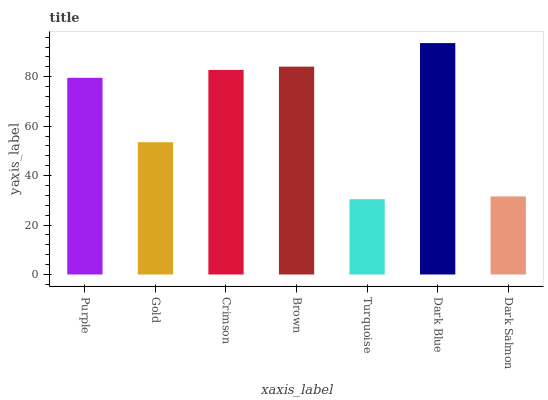Is Turquoise the minimum?
Answer yes or no. Yes. Is Dark Blue the maximum?
Answer yes or no. Yes. Is Gold the minimum?
Answer yes or no. No. Is Gold the maximum?
Answer yes or no. No. Is Purple greater than Gold?
Answer yes or no. Yes. Is Gold less than Purple?
Answer yes or no. Yes. Is Gold greater than Purple?
Answer yes or no. No. Is Purple less than Gold?
Answer yes or no. No. Is Purple the high median?
Answer yes or no. Yes. Is Purple the low median?
Answer yes or no. Yes. Is Dark Salmon the high median?
Answer yes or no. No. Is Dark Blue the low median?
Answer yes or no. No. 